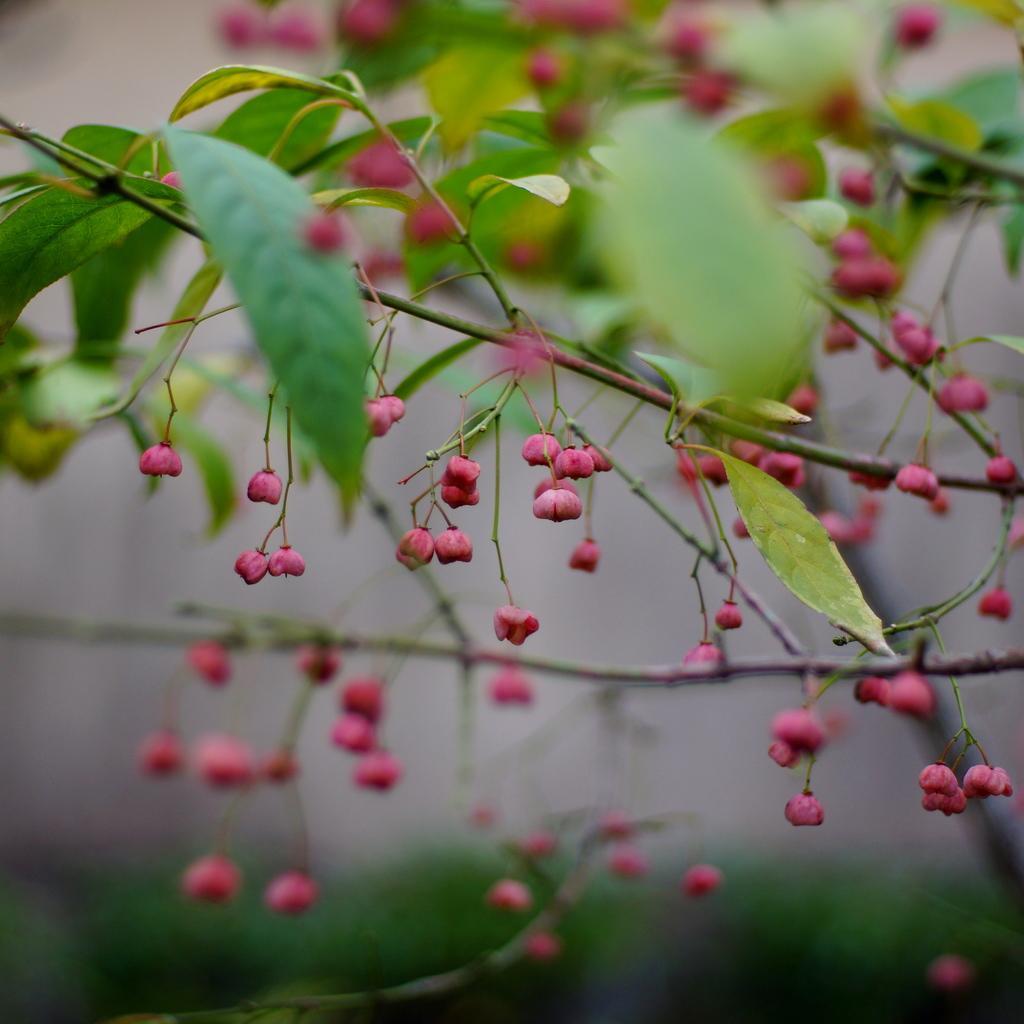How would you summarize this image in a sentence or two? In the center of the image there is a flower plant. 